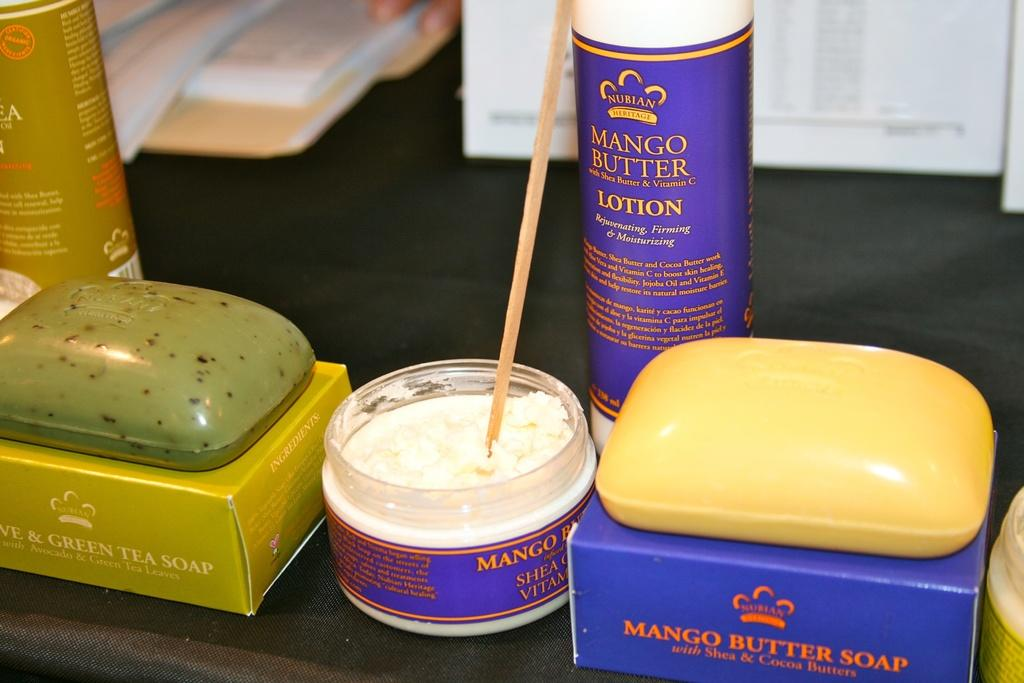<image>
Share a concise interpretation of the image provided. A series of toiletries one of which is mango butter soap. 